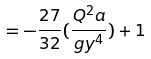Convert formula to latex. <formula><loc_0><loc_0><loc_500><loc_500>= - \frac { 2 7 } { 3 2 } ( \frac { Q ^ { 2 } a } { g y ^ { 4 } } ) + 1</formula> 